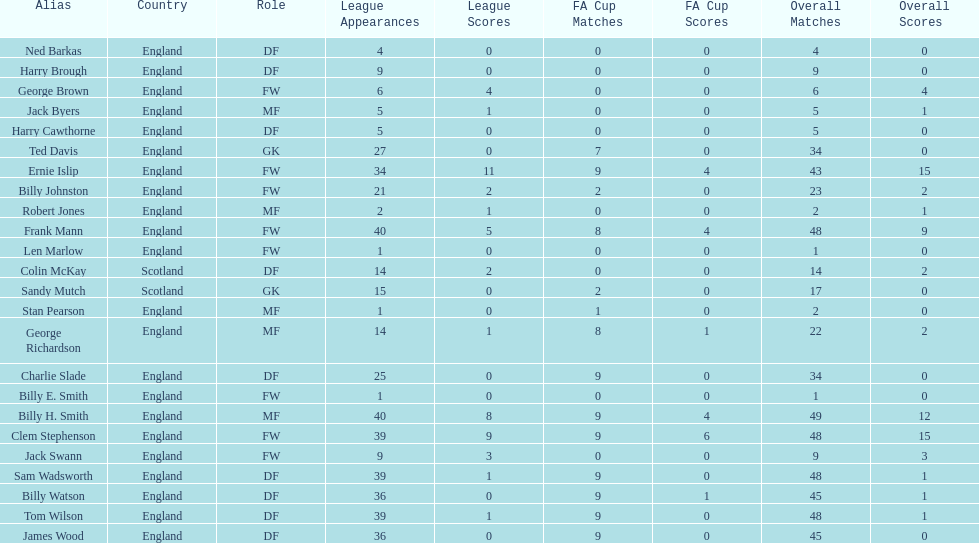What is the average number of scotland's total apps? 15.5. 